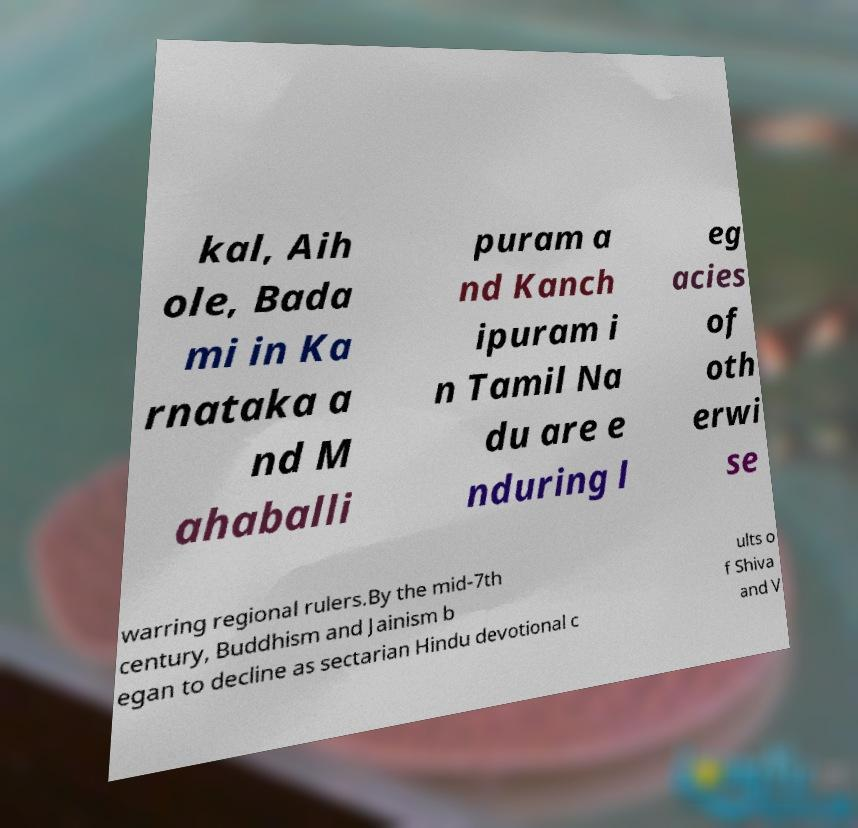For documentation purposes, I need the text within this image transcribed. Could you provide that? kal, Aih ole, Bada mi in Ka rnataka a nd M ahaballi puram a nd Kanch ipuram i n Tamil Na du are e nduring l eg acies of oth erwi se warring regional rulers.By the mid-7th century, Buddhism and Jainism b egan to decline as sectarian Hindu devotional c ults o f Shiva and V 